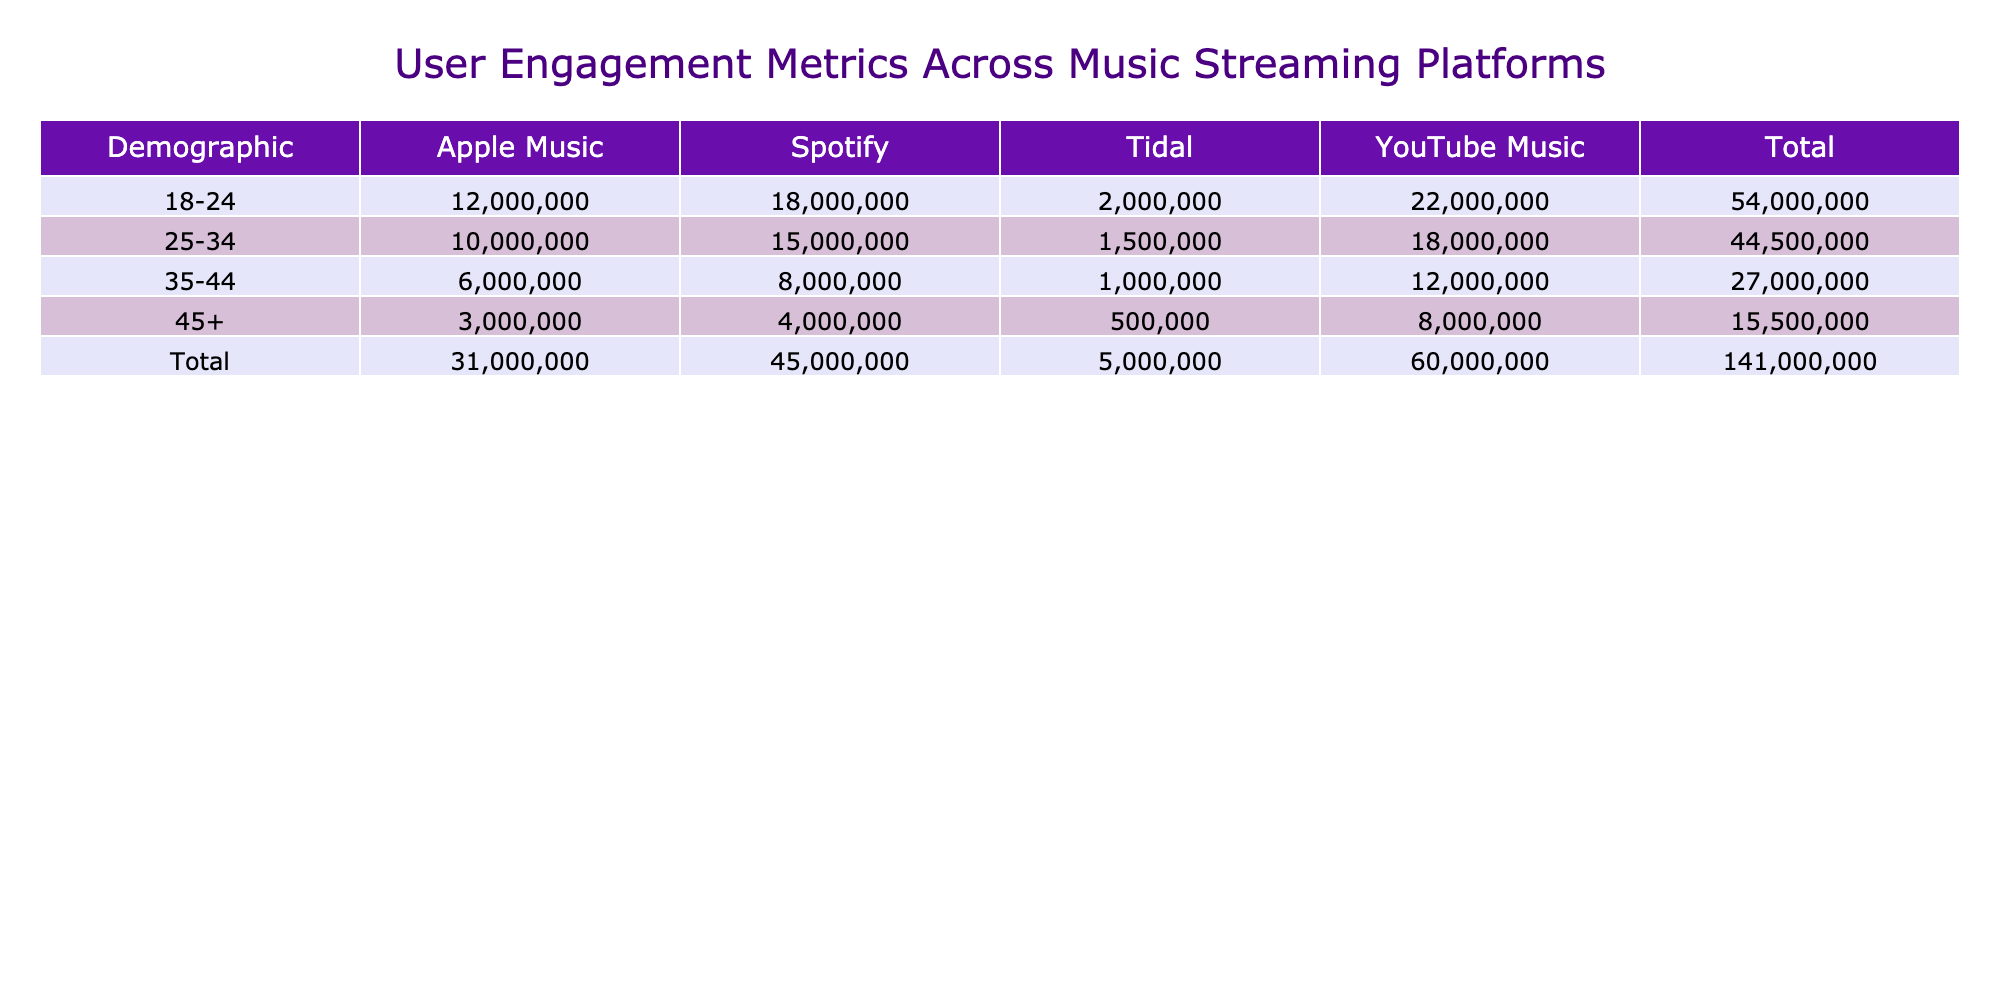What is the highest number of daily active users among the platforms for the 18-24 demographic? According to the table, YouTube Music has the highest value of 22000000 daily active users for the 18-24 demographic.
Answer: 22000000 Which platform has the lowest daily active users for the 35-44 demographic? For the 35-44 demographic, Tidal shows the lowest daily active users at 1000000.
Answer: 1000000 What is the total number of daily active users on Spotify across all demographics? Adding the daily active users for Spotify: 18000000 (18-24) + 15000000 (25-34) + 8000000 (35-44) + 4000000 (45+) gives a total of 43000000.
Answer: 43000000 Is the daily active user metric for Apple Music greater than 5000000 across all demographics? Checking the values, Apple Music has 12000000, 10000000, 6000000, and 3000000 for the different demographics. All values are greater than 5000000 for the first three age groups, but the last group (45+) is not, making the statement false overall.
Answer: No What is the average number of daily active users for YouTube Music across all age groups? The total daily active users for YouTube Music are: 22000000 (18-24) + 18000000 (25-34) + 12000000 (35-44) + 8000000 (45+) = 60000000. There are four age groups, so the average is 60000000 divided by 4, which equals 15000000.
Answer: 15000000 Which demographic shows the highest user engagement on Tidal? Looking at the table, the 18-24 demographic has the highest engagement on Tidal with 2000000 daily active users compared to lower figures for older demographics.
Answer: 2000000 How many more daily active users does YouTube Music have compared to Apple Music for the 25-34 demographic? YouTube Music has 18000000 daily active users, while Apple Music has 10000000. The difference is 18000000 minus 10000000, resulting in 8000000 more users.
Answer: 8000000 Do users aged 45 and above engage more with Spotify than Tidal? For the age group 45+, Spotify has 4000000 daily active users, while Tidal has only 500000. Since 4000000 is greater than 500000, the answer is yes.
Answer: Yes 